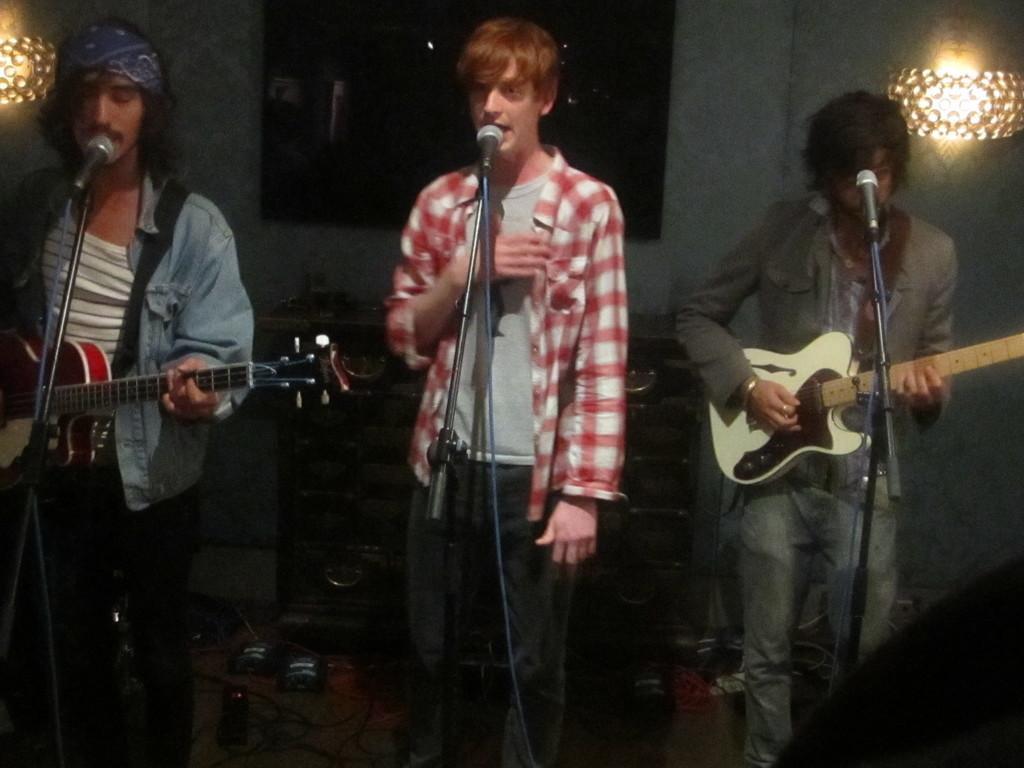Describe this image in one or two sentences. In this image I can see three people are standing in-front of the mic and two people are holding the musical instruments. Among them one person is wearing the red and white check shirt. Left side person is wearing a blue color band to the head. To the back them there is a table and lights. 